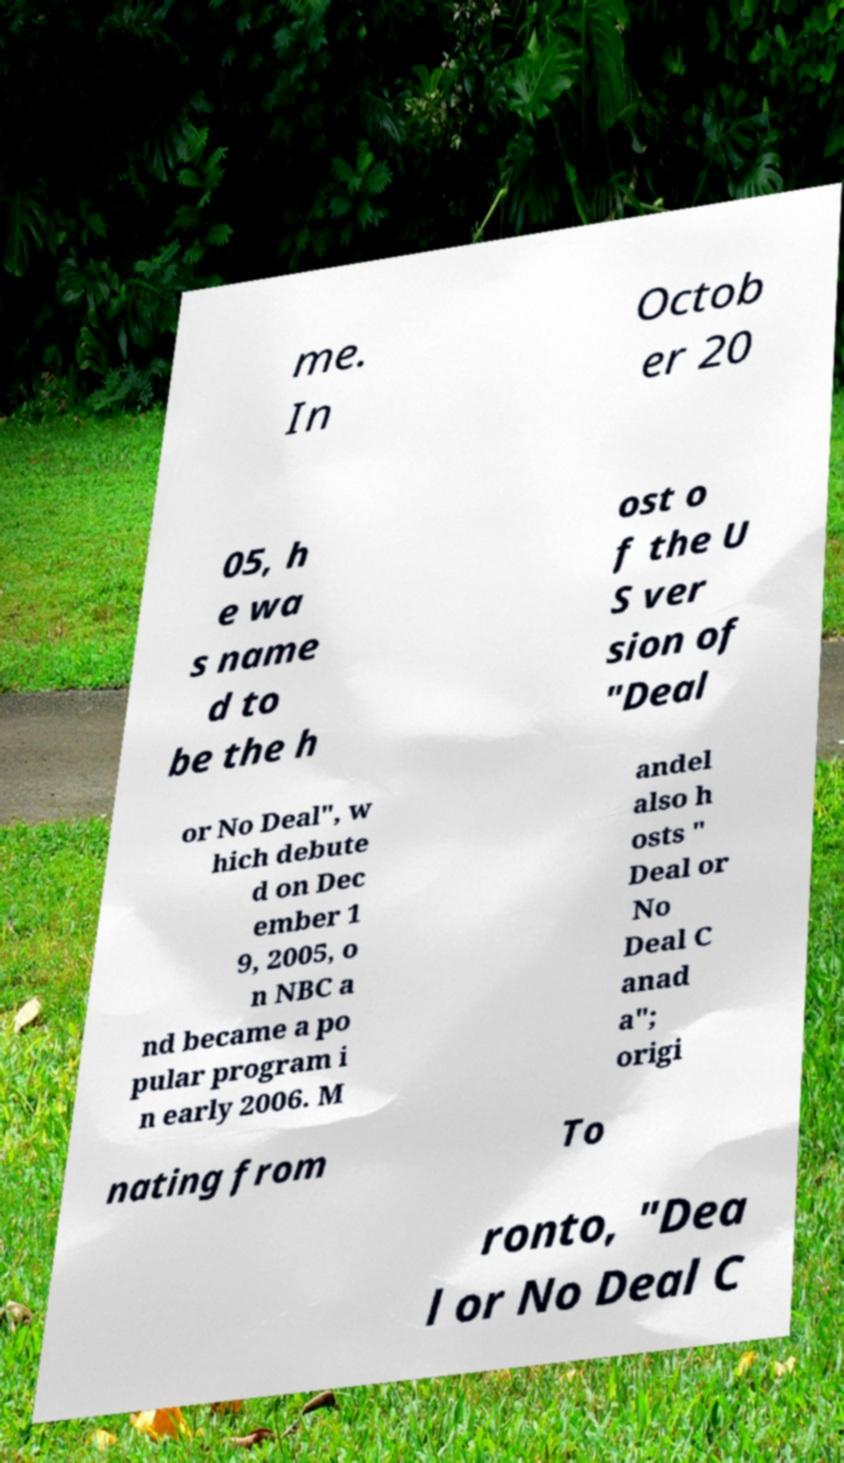For documentation purposes, I need the text within this image transcribed. Could you provide that? me. In Octob er 20 05, h e wa s name d to be the h ost o f the U S ver sion of "Deal or No Deal", w hich debute d on Dec ember 1 9, 2005, o n NBC a nd became a po pular program i n early 2006. M andel also h osts " Deal or No Deal C anad a"; origi nating from To ronto, "Dea l or No Deal C 